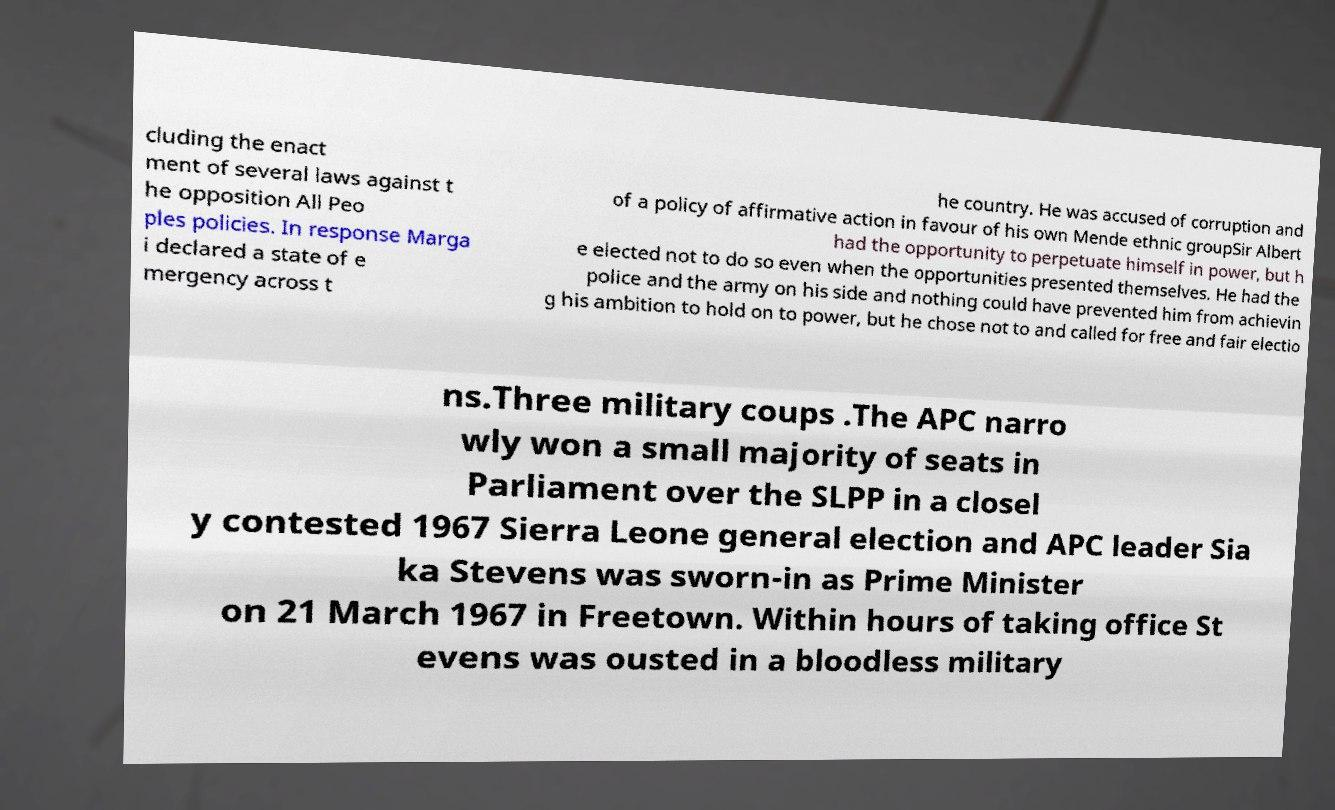Can you accurately transcribe the text from the provided image for me? cluding the enact ment of several laws against t he opposition All Peo ples policies. In response Marga i declared a state of e mergency across t he country. He was accused of corruption and of a policy of affirmative action in favour of his own Mende ethnic groupSir Albert had the opportunity to perpetuate himself in power, but h e elected not to do so even when the opportunities presented themselves. He had the police and the army on his side and nothing could have prevented him from achievin g his ambition to hold on to power, but he chose not to and called for free and fair electio ns.Three military coups .The APC narro wly won a small majority of seats in Parliament over the SLPP in a closel y contested 1967 Sierra Leone general election and APC leader Sia ka Stevens was sworn-in as Prime Minister on 21 March 1967 in Freetown. Within hours of taking office St evens was ousted in a bloodless military 